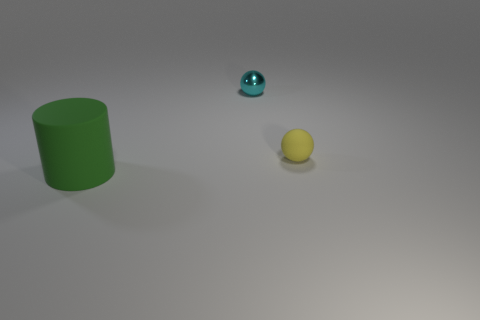Subtract 1 cylinders. How many cylinders are left? 0 Add 1 brown rubber objects. How many objects exist? 4 Subtract all yellow balls. How many balls are left? 1 Subtract all balls. How many objects are left? 1 Subtract 0 red cylinders. How many objects are left? 3 Subtract all purple spheres. Subtract all purple cylinders. How many spheres are left? 2 Subtract all blue cubes. How many gray spheres are left? 0 Subtract all tiny yellow rubber things. Subtract all yellow things. How many objects are left? 1 Add 3 cyan balls. How many cyan balls are left? 4 Add 1 large rubber cylinders. How many large rubber cylinders exist? 2 